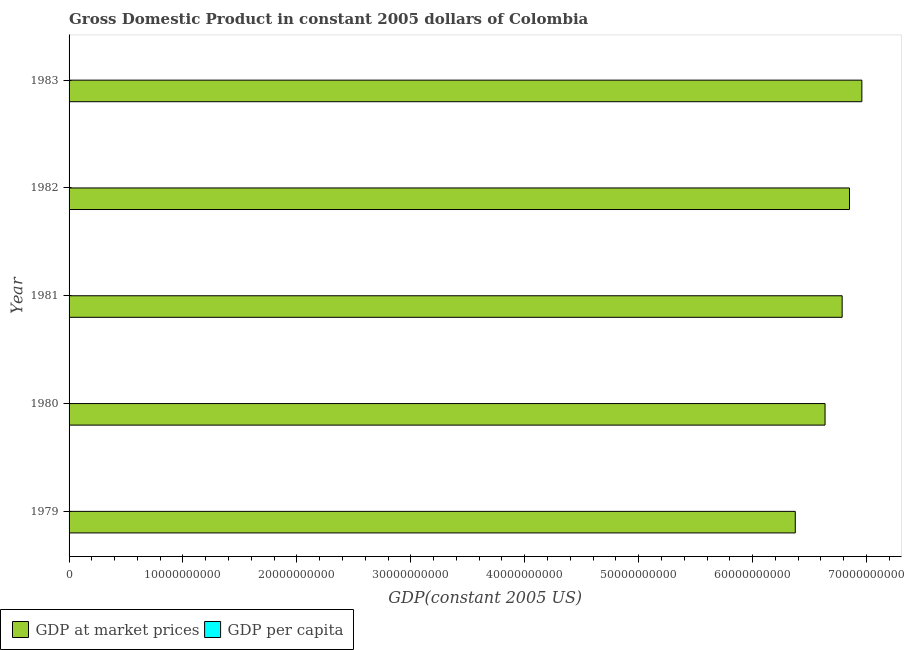How many groups of bars are there?
Your response must be concise. 5. Are the number of bars on each tick of the Y-axis equal?
Offer a terse response. Yes. How many bars are there on the 5th tick from the top?
Offer a very short reply. 2. What is the gdp per capita in 1980?
Offer a terse response. 2392.51. Across all years, what is the maximum gdp at market prices?
Provide a short and direct response. 6.96e+1. Across all years, what is the minimum gdp at market prices?
Offer a very short reply. 6.38e+1. In which year was the gdp per capita minimum?
Keep it short and to the point. 1983. What is the total gdp per capita in the graph?
Give a very brief answer. 1.18e+04. What is the difference between the gdp per capita in 1982 and that in 1983?
Provide a succinct answer. 15.9. What is the difference between the gdp at market prices in 1983 and the gdp per capita in 1981?
Keep it short and to the point. 6.96e+1. What is the average gdp at market prices per year?
Provide a short and direct response. 6.72e+1. In the year 1982, what is the difference between the gdp at market prices and gdp per capita?
Your answer should be very brief. 6.85e+1. What is the ratio of the gdp at market prices in 1980 to that in 1983?
Ensure brevity in your answer.  0.95. Is the difference between the gdp at market prices in 1979 and 1981 greater than the difference between the gdp per capita in 1979 and 1981?
Make the answer very short. No. What is the difference between the highest and the second highest gdp at market prices?
Make the answer very short. 1.09e+09. What is the difference between the highest and the lowest gdp per capita?
Your response must be concise. 48.25. In how many years, is the gdp at market prices greater than the average gdp at market prices taken over all years?
Your response must be concise. 3. What does the 1st bar from the top in 1979 represents?
Your answer should be very brief. GDP per capita. What does the 2nd bar from the bottom in 1981 represents?
Offer a very short reply. GDP per capita. Are the values on the major ticks of X-axis written in scientific E-notation?
Ensure brevity in your answer.  No. Does the graph contain any zero values?
Keep it short and to the point. No. Does the graph contain grids?
Your response must be concise. No. Where does the legend appear in the graph?
Your answer should be very brief. Bottom left. What is the title of the graph?
Your answer should be compact. Gross Domestic Product in constant 2005 dollars of Colombia. What is the label or title of the X-axis?
Provide a short and direct response. GDP(constant 2005 US). What is the label or title of the Y-axis?
Your answer should be very brief. Year. What is the GDP(constant 2005 US) of GDP at market prices in 1979?
Offer a very short reply. 6.38e+1. What is the GDP(constant 2005 US) in GDP per capita in 1979?
Your answer should be compact. 2351.25. What is the GDP(constant 2005 US) of GDP at market prices in 1980?
Provide a succinct answer. 6.64e+1. What is the GDP(constant 2005 US) of GDP per capita in 1980?
Your answer should be very brief. 2392.51. What is the GDP(constant 2005 US) of GDP at market prices in 1981?
Ensure brevity in your answer.  6.79e+1. What is the GDP(constant 2005 US) in GDP per capita in 1981?
Provide a short and direct response. 2391.64. What is the GDP(constant 2005 US) of GDP at market prices in 1982?
Your response must be concise. 6.85e+1. What is the GDP(constant 2005 US) in GDP per capita in 1982?
Provide a short and direct response. 2360.17. What is the GDP(constant 2005 US) of GDP at market prices in 1983?
Your response must be concise. 6.96e+1. What is the GDP(constant 2005 US) in GDP per capita in 1983?
Offer a very short reply. 2344.26. Across all years, what is the maximum GDP(constant 2005 US) in GDP at market prices?
Your answer should be very brief. 6.96e+1. Across all years, what is the maximum GDP(constant 2005 US) in GDP per capita?
Make the answer very short. 2392.51. Across all years, what is the minimum GDP(constant 2005 US) in GDP at market prices?
Offer a terse response. 6.38e+1. Across all years, what is the minimum GDP(constant 2005 US) of GDP per capita?
Offer a very short reply. 2344.26. What is the total GDP(constant 2005 US) of GDP at market prices in the graph?
Provide a succinct answer. 3.36e+11. What is the total GDP(constant 2005 US) in GDP per capita in the graph?
Make the answer very short. 1.18e+04. What is the difference between the GDP(constant 2005 US) in GDP at market prices in 1979 and that in 1980?
Ensure brevity in your answer.  -2.61e+09. What is the difference between the GDP(constant 2005 US) of GDP per capita in 1979 and that in 1980?
Your answer should be very brief. -41.26. What is the difference between the GDP(constant 2005 US) of GDP at market prices in 1979 and that in 1981?
Your answer should be compact. -4.11e+09. What is the difference between the GDP(constant 2005 US) of GDP per capita in 1979 and that in 1981?
Keep it short and to the point. -40.39. What is the difference between the GDP(constant 2005 US) of GDP at market prices in 1979 and that in 1982?
Make the answer very short. -4.76e+09. What is the difference between the GDP(constant 2005 US) of GDP per capita in 1979 and that in 1982?
Your answer should be very brief. -8.92. What is the difference between the GDP(constant 2005 US) in GDP at market prices in 1979 and that in 1983?
Keep it short and to the point. -5.84e+09. What is the difference between the GDP(constant 2005 US) of GDP per capita in 1979 and that in 1983?
Keep it short and to the point. 6.99. What is the difference between the GDP(constant 2005 US) of GDP at market prices in 1980 and that in 1981?
Provide a short and direct response. -1.50e+09. What is the difference between the GDP(constant 2005 US) in GDP per capita in 1980 and that in 1981?
Your answer should be compact. 0.87. What is the difference between the GDP(constant 2005 US) in GDP at market prices in 1980 and that in 1982?
Offer a very short reply. -2.15e+09. What is the difference between the GDP(constant 2005 US) of GDP per capita in 1980 and that in 1982?
Your answer should be compact. 32.35. What is the difference between the GDP(constant 2005 US) in GDP at market prices in 1980 and that in 1983?
Ensure brevity in your answer.  -3.23e+09. What is the difference between the GDP(constant 2005 US) in GDP per capita in 1980 and that in 1983?
Provide a short and direct response. 48.25. What is the difference between the GDP(constant 2005 US) in GDP at market prices in 1981 and that in 1982?
Make the answer very short. -6.44e+08. What is the difference between the GDP(constant 2005 US) of GDP per capita in 1981 and that in 1982?
Give a very brief answer. 31.48. What is the difference between the GDP(constant 2005 US) in GDP at market prices in 1981 and that in 1983?
Give a very brief answer. -1.73e+09. What is the difference between the GDP(constant 2005 US) of GDP per capita in 1981 and that in 1983?
Offer a very short reply. 47.38. What is the difference between the GDP(constant 2005 US) in GDP at market prices in 1982 and that in 1983?
Offer a very short reply. -1.09e+09. What is the difference between the GDP(constant 2005 US) of GDP per capita in 1982 and that in 1983?
Give a very brief answer. 15.9. What is the difference between the GDP(constant 2005 US) of GDP at market prices in 1979 and the GDP(constant 2005 US) of GDP per capita in 1980?
Your answer should be very brief. 6.38e+1. What is the difference between the GDP(constant 2005 US) of GDP at market prices in 1979 and the GDP(constant 2005 US) of GDP per capita in 1981?
Provide a succinct answer. 6.38e+1. What is the difference between the GDP(constant 2005 US) of GDP at market prices in 1979 and the GDP(constant 2005 US) of GDP per capita in 1982?
Your answer should be very brief. 6.38e+1. What is the difference between the GDP(constant 2005 US) of GDP at market prices in 1979 and the GDP(constant 2005 US) of GDP per capita in 1983?
Make the answer very short. 6.38e+1. What is the difference between the GDP(constant 2005 US) of GDP at market prices in 1980 and the GDP(constant 2005 US) of GDP per capita in 1981?
Ensure brevity in your answer.  6.64e+1. What is the difference between the GDP(constant 2005 US) in GDP at market prices in 1980 and the GDP(constant 2005 US) in GDP per capita in 1982?
Provide a short and direct response. 6.64e+1. What is the difference between the GDP(constant 2005 US) in GDP at market prices in 1980 and the GDP(constant 2005 US) in GDP per capita in 1983?
Make the answer very short. 6.64e+1. What is the difference between the GDP(constant 2005 US) of GDP at market prices in 1981 and the GDP(constant 2005 US) of GDP per capita in 1982?
Keep it short and to the point. 6.79e+1. What is the difference between the GDP(constant 2005 US) of GDP at market prices in 1981 and the GDP(constant 2005 US) of GDP per capita in 1983?
Ensure brevity in your answer.  6.79e+1. What is the difference between the GDP(constant 2005 US) of GDP at market prices in 1982 and the GDP(constant 2005 US) of GDP per capita in 1983?
Provide a succinct answer. 6.85e+1. What is the average GDP(constant 2005 US) in GDP at market prices per year?
Give a very brief answer. 6.72e+1. What is the average GDP(constant 2005 US) in GDP per capita per year?
Your response must be concise. 2367.97. In the year 1979, what is the difference between the GDP(constant 2005 US) of GDP at market prices and GDP(constant 2005 US) of GDP per capita?
Your answer should be very brief. 6.38e+1. In the year 1980, what is the difference between the GDP(constant 2005 US) of GDP at market prices and GDP(constant 2005 US) of GDP per capita?
Give a very brief answer. 6.64e+1. In the year 1981, what is the difference between the GDP(constant 2005 US) in GDP at market prices and GDP(constant 2005 US) in GDP per capita?
Ensure brevity in your answer.  6.79e+1. In the year 1982, what is the difference between the GDP(constant 2005 US) in GDP at market prices and GDP(constant 2005 US) in GDP per capita?
Provide a short and direct response. 6.85e+1. In the year 1983, what is the difference between the GDP(constant 2005 US) of GDP at market prices and GDP(constant 2005 US) of GDP per capita?
Keep it short and to the point. 6.96e+1. What is the ratio of the GDP(constant 2005 US) of GDP at market prices in 1979 to that in 1980?
Offer a terse response. 0.96. What is the ratio of the GDP(constant 2005 US) in GDP per capita in 1979 to that in 1980?
Your answer should be compact. 0.98. What is the ratio of the GDP(constant 2005 US) of GDP at market prices in 1979 to that in 1981?
Provide a short and direct response. 0.94. What is the ratio of the GDP(constant 2005 US) in GDP per capita in 1979 to that in 1981?
Keep it short and to the point. 0.98. What is the ratio of the GDP(constant 2005 US) in GDP at market prices in 1979 to that in 1982?
Make the answer very short. 0.93. What is the ratio of the GDP(constant 2005 US) of GDP per capita in 1979 to that in 1982?
Ensure brevity in your answer.  1. What is the ratio of the GDP(constant 2005 US) of GDP at market prices in 1979 to that in 1983?
Give a very brief answer. 0.92. What is the ratio of the GDP(constant 2005 US) in GDP per capita in 1979 to that in 1983?
Offer a terse response. 1. What is the ratio of the GDP(constant 2005 US) in GDP at market prices in 1980 to that in 1981?
Provide a succinct answer. 0.98. What is the ratio of the GDP(constant 2005 US) of GDP at market prices in 1980 to that in 1982?
Provide a short and direct response. 0.97. What is the ratio of the GDP(constant 2005 US) of GDP per capita in 1980 to that in 1982?
Offer a very short reply. 1.01. What is the ratio of the GDP(constant 2005 US) of GDP at market prices in 1980 to that in 1983?
Ensure brevity in your answer.  0.95. What is the ratio of the GDP(constant 2005 US) in GDP per capita in 1980 to that in 1983?
Your answer should be very brief. 1.02. What is the ratio of the GDP(constant 2005 US) in GDP at market prices in 1981 to that in 1982?
Your answer should be compact. 0.99. What is the ratio of the GDP(constant 2005 US) in GDP per capita in 1981 to that in 1982?
Give a very brief answer. 1.01. What is the ratio of the GDP(constant 2005 US) in GDP at market prices in 1981 to that in 1983?
Offer a very short reply. 0.98. What is the ratio of the GDP(constant 2005 US) of GDP per capita in 1981 to that in 1983?
Your answer should be very brief. 1.02. What is the ratio of the GDP(constant 2005 US) of GDP at market prices in 1982 to that in 1983?
Make the answer very short. 0.98. What is the ratio of the GDP(constant 2005 US) of GDP per capita in 1982 to that in 1983?
Offer a terse response. 1.01. What is the difference between the highest and the second highest GDP(constant 2005 US) in GDP at market prices?
Your answer should be very brief. 1.09e+09. What is the difference between the highest and the second highest GDP(constant 2005 US) of GDP per capita?
Make the answer very short. 0.87. What is the difference between the highest and the lowest GDP(constant 2005 US) in GDP at market prices?
Your answer should be compact. 5.84e+09. What is the difference between the highest and the lowest GDP(constant 2005 US) of GDP per capita?
Ensure brevity in your answer.  48.25. 